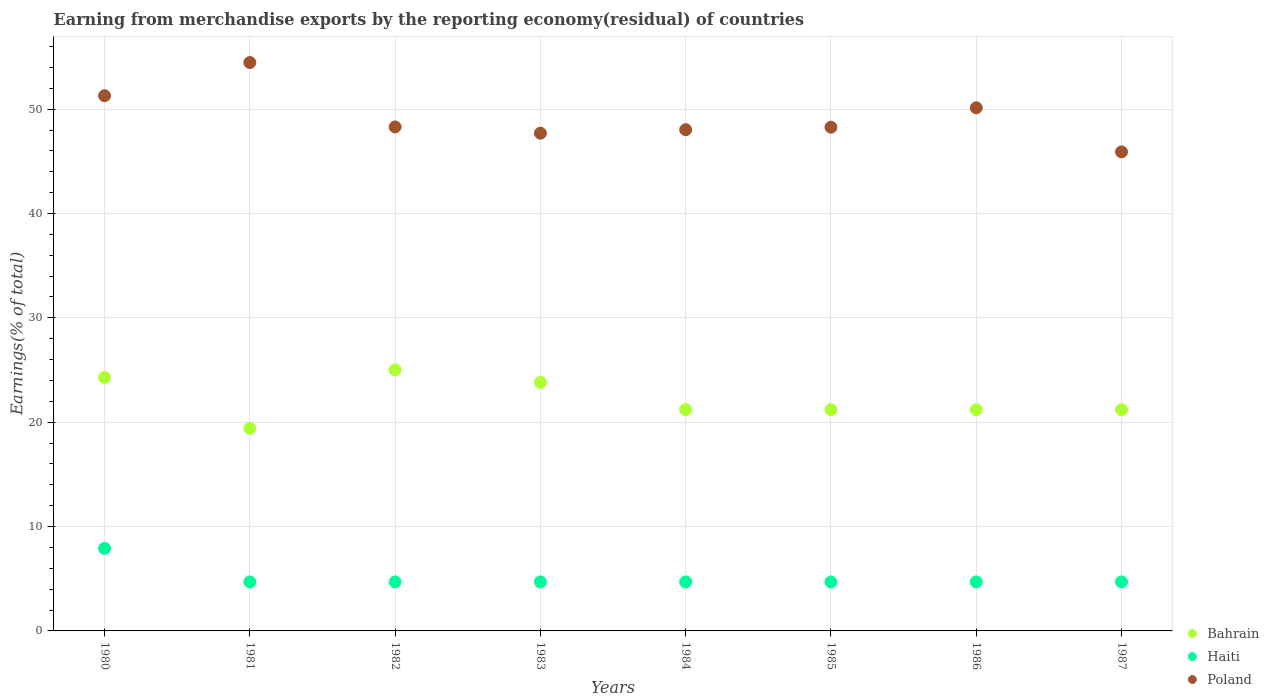How many different coloured dotlines are there?
Keep it short and to the point. 3. What is the percentage of amount earned from merchandise exports in Bahrain in 1986?
Keep it short and to the point. 21.2. Across all years, what is the maximum percentage of amount earned from merchandise exports in Bahrain?
Your answer should be compact. 25.02. Across all years, what is the minimum percentage of amount earned from merchandise exports in Haiti?
Offer a very short reply. 4.7. In which year was the percentage of amount earned from merchandise exports in Haiti minimum?
Offer a terse response. 1983. What is the total percentage of amount earned from merchandise exports in Haiti in the graph?
Your answer should be compact. 40.8. What is the difference between the percentage of amount earned from merchandise exports in Haiti in 1981 and that in 1985?
Ensure brevity in your answer.  1.0363631730569978e-8. What is the difference between the percentage of amount earned from merchandise exports in Haiti in 1983 and the percentage of amount earned from merchandise exports in Bahrain in 1981?
Your answer should be compact. -14.71. What is the average percentage of amount earned from merchandise exports in Bahrain per year?
Make the answer very short. 22.17. In the year 1987, what is the difference between the percentage of amount earned from merchandise exports in Poland and percentage of amount earned from merchandise exports in Bahrain?
Give a very brief answer. 24.71. In how many years, is the percentage of amount earned from merchandise exports in Bahrain greater than 48 %?
Give a very brief answer. 0. What is the ratio of the percentage of amount earned from merchandise exports in Haiti in 1983 to that in 1985?
Your answer should be very brief. 1. Is the percentage of amount earned from merchandise exports in Bahrain in 1980 less than that in 1983?
Offer a terse response. No. What is the difference between the highest and the second highest percentage of amount earned from merchandise exports in Bahrain?
Provide a short and direct response. 0.72. What is the difference between the highest and the lowest percentage of amount earned from merchandise exports in Bahrain?
Offer a very short reply. 5.6. In how many years, is the percentage of amount earned from merchandise exports in Bahrain greater than the average percentage of amount earned from merchandise exports in Bahrain taken over all years?
Give a very brief answer. 3. Is the sum of the percentage of amount earned from merchandise exports in Poland in 1980 and 1984 greater than the maximum percentage of amount earned from merchandise exports in Bahrain across all years?
Ensure brevity in your answer.  Yes. Does the percentage of amount earned from merchandise exports in Bahrain monotonically increase over the years?
Give a very brief answer. No. Are the values on the major ticks of Y-axis written in scientific E-notation?
Your response must be concise. No. How many legend labels are there?
Your answer should be very brief. 3. How are the legend labels stacked?
Your answer should be very brief. Vertical. What is the title of the graph?
Provide a short and direct response. Earning from merchandise exports by the reporting economy(residual) of countries. What is the label or title of the Y-axis?
Give a very brief answer. Earnings(% of total). What is the Earnings(% of total) in Bahrain in 1980?
Offer a terse response. 24.29. What is the Earnings(% of total) of Haiti in 1980?
Offer a very short reply. 7.91. What is the Earnings(% of total) of Poland in 1980?
Give a very brief answer. 51.29. What is the Earnings(% of total) of Bahrain in 1981?
Ensure brevity in your answer.  19.41. What is the Earnings(% of total) in Haiti in 1981?
Offer a very short reply. 4.7. What is the Earnings(% of total) of Poland in 1981?
Your answer should be very brief. 54.47. What is the Earnings(% of total) of Bahrain in 1982?
Make the answer very short. 25.02. What is the Earnings(% of total) in Haiti in 1982?
Provide a succinct answer. 4.7. What is the Earnings(% of total) of Poland in 1982?
Offer a terse response. 48.3. What is the Earnings(% of total) of Bahrain in 1983?
Make the answer very short. 23.83. What is the Earnings(% of total) in Haiti in 1983?
Ensure brevity in your answer.  4.7. What is the Earnings(% of total) in Poland in 1983?
Your answer should be very brief. 47.7. What is the Earnings(% of total) of Bahrain in 1984?
Your response must be concise. 21.2. What is the Earnings(% of total) of Haiti in 1984?
Keep it short and to the point. 4.7. What is the Earnings(% of total) of Poland in 1984?
Your answer should be compact. 48.03. What is the Earnings(% of total) of Bahrain in 1985?
Offer a terse response. 21.2. What is the Earnings(% of total) of Haiti in 1985?
Offer a very short reply. 4.7. What is the Earnings(% of total) of Poland in 1985?
Your answer should be very brief. 48.27. What is the Earnings(% of total) in Bahrain in 1986?
Ensure brevity in your answer.  21.2. What is the Earnings(% of total) of Haiti in 1986?
Offer a very short reply. 4.7. What is the Earnings(% of total) of Poland in 1986?
Your response must be concise. 50.13. What is the Earnings(% of total) in Bahrain in 1987?
Make the answer very short. 21.2. What is the Earnings(% of total) in Haiti in 1987?
Keep it short and to the point. 4.7. What is the Earnings(% of total) of Poland in 1987?
Ensure brevity in your answer.  45.91. Across all years, what is the maximum Earnings(% of total) in Bahrain?
Your response must be concise. 25.02. Across all years, what is the maximum Earnings(% of total) of Haiti?
Make the answer very short. 7.91. Across all years, what is the maximum Earnings(% of total) of Poland?
Your response must be concise. 54.47. Across all years, what is the minimum Earnings(% of total) in Bahrain?
Give a very brief answer. 19.41. Across all years, what is the minimum Earnings(% of total) of Haiti?
Keep it short and to the point. 4.7. Across all years, what is the minimum Earnings(% of total) of Poland?
Your answer should be very brief. 45.91. What is the total Earnings(% of total) of Bahrain in the graph?
Keep it short and to the point. 177.35. What is the total Earnings(% of total) of Haiti in the graph?
Ensure brevity in your answer.  40.8. What is the total Earnings(% of total) of Poland in the graph?
Your answer should be very brief. 394.09. What is the difference between the Earnings(% of total) in Bahrain in 1980 and that in 1981?
Give a very brief answer. 4.88. What is the difference between the Earnings(% of total) of Haiti in 1980 and that in 1981?
Provide a short and direct response. 3.21. What is the difference between the Earnings(% of total) in Poland in 1980 and that in 1981?
Offer a terse response. -3.18. What is the difference between the Earnings(% of total) in Bahrain in 1980 and that in 1982?
Your answer should be compact. -0.72. What is the difference between the Earnings(% of total) of Haiti in 1980 and that in 1982?
Your response must be concise. 3.21. What is the difference between the Earnings(% of total) of Poland in 1980 and that in 1982?
Offer a terse response. 2.99. What is the difference between the Earnings(% of total) in Bahrain in 1980 and that in 1983?
Your answer should be compact. 0.47. What is the difference between the Earnings(% of total) of Haiti in 1980 and that in 1983?
Ensure brevity in your answer.  3.21. What is the difference between the Earnings(% of total) of Poland in 1980 and that in 1983?
Provide a succinct answer. 3.59. What is the difference between the Earnings(% of total) in Bahrain in 1980 and that in 1984?
Your response must be concise. 3.09. What is the difference between the Earnings(% of total) in Haiti in 1980 and that in 1984?
Ensure brevity in your answer.  3.21. What is the difference between the Earnings(% of total) of Poland in 1980 and that in 1984?
Your answer should be very brief. 3.26. What is the difference between the Earnings(% of total) in Bahrain in 1980 and that in 1985?
Offer a terse response. 3.09. What is the difference between the Earnings(% of total) of Haiti in 1980 and that in 1985?
Your response must be concise. 3.21. What is the difference between the Earnings(% of total) of Poland in 1980 and that in 1985?
Offer a terse response. 3.02. What is the difference between the Earnings(% of total) of Bahrain in 1980 and that in 1986?
Your answer should be very brief. 3.09. What is the difference between the Earnings(% of total) in Haiti in 1980 and that in 1986?
Your response must be concise. 3.21. What is the difference between the Earnings(% of total) of Poland in 1980 and that in 1986?
Provide a short and direct response. 1.16. What is the difference between the Earnings(% of total) in Bahrain in 1980 and that in 1987?
Give a very brief answer. 3.09. What is the difference between the Earnings(% of total) in Haiti in 1980 and that in 1987?
Your answer should be compact. 3.21. What is the difference between the Earnings(% of total) in Poland in 1980 and that in 1987?
Offer a terse response. 5.38. What is the difference between the Earnings(% of total) of Bahrain in 1981 and that in 1982?
Make the answer very short. -5.6. What is the difference between the Earnings(% of total) of Haiti in 1981 and that in 1982?
Ensure brevity in your answer.  0. What is the difference between the Earnings(% of total) of Poland in 1981 and that in 1982?
Ensure brevity in your answer.  6.17. What is the difference between the Earnings(% of total) of Bahrain in 1981 and that in 1983?
Keep it short and to the point. -4.41. What is the difference between the Earnings(% of total) in Poland in 1981 and that in 1983?
Keep it short and to the point. 6.77. What is the difference between the Earnings(% of total) of Bahrain in 1981 and that in 1984?
Your response must be concise. -1.79. What is the difference between the Earnings(% of total) in Poland in 1981 and that in 1984?
Offer a terse response. 6.44. What is the difference between the Earnings(% of total) in Bahrain in 1981 and that in 1985?
Your answer should be compact. -1.79. What is the difference between the Earnings(% of total) in Poland in 1981 and that in 1985?
Your answer should be compact. 6.2. What is the difference between the Earnings(% of total) of Bahrain in 1981 and that in 1986?
Your answer should be compact. -1.79. What is the difference between the Earnings(% of total) in Poland in 1981 and that in 1986?
Give a very brief answer. 4.34. What is the difference between the Earnings(% of total) of Bahrain in 1981 and that in 1987?
Give a very brief answer. -1.79. What is the difference between the Earnings(% of total) in Haiti in 1981 and that in 1987?
Give a very brief answer. -0. What is the difference between the Earnings(% of total) of Poland in 1981 and that in 1987?
Provide a short and direct response. 8.56. What is the difference between the Earnings(% of total) of Bahrain in 1982 and that in 1983?
Ensure brevity in your answer.  1.19. What is the difference between the Earnings(% of total) of Haiti in 1982 and that in 1983?
Provide a short and direct response. 0. What is the difference between the Earnings(% of total) in Poland in 1982 and that in 1983?
Make the answer very short. 0.6. What is the difference between the Earnings(% of total) of Bahrain in 1982 and that in 1984?
Offer a terse response. 3.82. What is the difference between the Earnings(% of total) of Poland in 1982 and that in 1984?
Your answer should be very brief. 0.27. What is the difference between the Earnings(% of total) of Bahrain in 1982 and that in 1985?
Give a very brief answer. 3.82. What is the difference between the Earnings(% of total) in Haiti in 1982 and that in 1985?
Keep it short and to the point. -0. What is the difference between the Earnings(% of total) of Poland in 1982 and that in 1985?
Ensure brevity in your answer.  0.03. What is the difference between the Earnings(% of total) in Bahrain in 1982 and that in 1986?
Your response must be concise. 3.82. What is the difference between the Earnings(% of total) in Haiti in 1982 and that in 1986?
Ensure brevity in your answer.  -0. What is the difference between the Earnings(% of total) of Poland in 1982 and that in 1986?
Give a very brief answer. -1.83. What is the difference between the Earnings(% of total) in Bahrain in 1982 and that in 1987?
Your answer should be compact. 3.82. What is the difference between the Earnings(% of total) in Haiti in 1982 and that in 1987?
Your response must be concise. -0. What is the difference between the Earnings(% of total) in Poland in 1982 and that in 1987?
Offer a terse response. 2.39. What is the difference between the Earnings(% of total) of Bahrain in 1983 and that in 1984?
Keep it short and to the point. 2.63. What is the difference between the Earnings(% of total) of Haiti in 1983 and that in 1984?
Offer a terse response. -0. What is the difference between the Earnings(% of total) in Poland in 1983 and that in 1984?
Your answer should be very brief. -0.34. What is the difference between the Earnings(% of total) in Bahrain in 1983 and that in 1985?
Provide a succinct answer. 2.63. What is the difference between the Earnings(% of total) of Poland in 1983 and that in 1985?
Keep it short and to the point. -0.57. What is the difference between the Earnings(% of total) in Bahrain in 1983 and that in 1986?
Ensure brevity in your answer.  2.63. What is the difference between the Earnings(% of total) of Poland in 1983 and that in 1986?
Provide a succinct answer. -2.44. What is the difference between the Earnings(% of total) of Bahrain in 1983 and that in 1987?
Your response must be concise. 2.63. What is the difference between the Earnings(% of total) in Poland in 1983 and that in 1987?
Ensure brevity in your answer.  1.79. What is the difference between the Earnings(% of total) in Poland in 1984 and that in 1985?
Your answer should be very brief. -0.24. What is the difference between the Earnings(% of total) of Bahrain in 1984 and that in 1986?
Your answer should be very brief. -0. What is the difference between the Earnings(% of total) of Poland in 1984 and that in 1986?
Offer a terse response. -2.1. What is the difference between the Earnings(% of total) of Bahrain in 1984 and that in 1987?
Keep it short and to the point. -0. What is the difference between the Earnings(% of total) of Poland in 1984 and that in 1987?
Offer a very short reply. 2.13. What is the difference between the Earnings(% of total) in Bahrain in 1985 and that in 1986?
Offer a very short reply. 0. What is the difference between the Earnings(% of total) of Haiti in 1985 and that in 1986?
Provide a short and direct response. -0. What is the difference between the Earnings(% of total) in Poland in 1985 and that in 1986?
Provide a short and direct response. -1.86. What is the difference between the Earnings(% of total) of Bahrain in 1985 and that in 1987?
Your answer should be compact. -0. What is the difference between the Earnings(% of total) in Haiti in 1985 and that in 1987?
Offer a very short reply. -0. What is the difference between the Earnings(% of total) in Poland in 1985 and that in 1987?
Give a very brief answer. 2.37. What is the difference between the Earnings(% of total) in Haiti in 1986 and that in 1987?
Your answer should be very brief. 0. What is the difference between the Earnings(% of total) of Poland in 1986 and that in 1987?
Provide a succinct answer. 4.23. What is the difference between the Earnings(% of total) of Bahrain in 1980 and the Earnings(% of total) of Haiti in 1981?
Offer a very short reply. 19.59. What is the difference between the Earnings(% of total) of Bahrain in 1980 and the Earnings(% of total) of Poland in 1981?
Your answer should be compact. -30.18. What is the difference between the Earnings(% of total) in Haiti in 1980 and the Earnings(% of total) in Poland in 1981?
Make the answer very short. -46.56. What is the difference between the Earnings(% of total) in Bahrain in 1980 and the Earnings(% of total) in Haiti in 1982?
Your answer should be very brief. 19.59. What is the difference between the Earnings(% of total) of Bahrain in 1980 and the Earnings(% of total) of Poland in 1982?
Ensure brevity in your answer.  -24.01. What is the difference between the Earnings(% of total) in Haiti in 1980 and the Earnings(% of total) in Poland in 1982?
Provide a short and direct response. -40.39. What is the difference between the Earnings(% of total) in Bahrain in 1980 and the Earnings(% of total) in Haiti in 1983?
Keep it short and to the point. 19.59. What is the difference between the Earnings(% of total) in Bahrain in 1980 and the Earnings(% of total) in Poland in 1983?
Offer a terse response. -23.4. What is the difference between the Earnings(% of total) in Haiti in 1980 and the Earnings(% of total) in Poland in 1983?
Provide a succinct answer. -39.78. What is the difference between the Earnings(% of total) of Bahrain in 1980 and the Earnings(% of total) of Haiti in 1984?
Your answer should be very brief. 19.59. What is the difference between the Earnings(% of total) in Bahrain in 1980 and the Earnings(% of total) in Poland in 1984?
Offer a terse response. -23.74. What is the difference between the Earnings(% of total) in Haiti in 1980 and the Earnings(% of total) in Poland in 1984?
Your response must be concise. -40.12. What is the difference between the Earnings(% of total) of Bahrain in 1980 and the Earnings(% of total) of Haiti in 1985?
Offer a very short reply. 19.59. What is the difference between the Earnings(% of total) in Bahrain in 1980 and the Earnings(% of total) in Poland in 1985?
Your answer should be very brief. -23.98. What is the difference between the Earnings(% of total) in Haiti in 1980 and the Earnings(% of total) in Poland in 1985?
Your answer should be compact. -40.36. What is the difference between the Earnings(% of total) of Bahrain in 1980 and the Earnings(% of total) of Haiti in 1986?
Your answer should be compact. 19.59. What is the difference between the Earnings(% of total) of Bahrain in 1980 and the Earnings(% of total) of Poland in 1986?
Keep it short and to the point. -25.84. What is the difference between the Earnings(% of total) in Haiti in 1980 and the Earnings(% of total) in Poland in 1986?
Make the answer very short. -42.22. What is the difference between the Earnings(% of total) in Bahrain in 1980 and the Earnings(% of total) in Haiti in 1987?
Offer a very short reply. 19.59. What is the difference between the Earnings(% of total) in Bahrain in 1980 and the Earnings(% of total) in Poland in 1987?
Your answer should be very brief. -21.61. What is the difference between the Earnings(% of total) of Haiti in 1980 and the Earnings(% of total) of Poland in 1987?
Give a very brief answer. -37.99. What is the difference between the Earnings(% of total) in Bahrain in 1981 and the Earnings(% of total) in Haiti in 1982?
Keep it short and to the point. 14.71. What is the difference between the Earnings(% of total) of Bahrain in 1981 and the Earnings(% of total) of Poland in 1982?
Provide a short and direct response. -28.89. What is the difference between the Earnings(% of total) of Haiti in 1981 and the Earnings(% of total) of Poland in 1982?
Keep it short and to the point. -43.6. What is the difference between the Earnings(% of total) of Bahrain in 1981 and the Earnings(% of total) of Haiti in 1983?
Make the answer very short. 14.71. What is the difference between the Earnings(% of total) of Bahrain in 1981 and the Earnings(% of total) of Poland in 1983?
Give a very brief answer. -28.28. What is the difference between the Earnings(% of total) in Haiti in 1981 and the Earnings(% of total) in Poland in 1983?
Your response must be concise. -43. What is the difference between the Earnings(% of total) of Bahrain in 1981 and the Earnings(% of total) of Haiti in 1984?
Keep it short and to the point. 14.71. What is the difference between the Earnings(% of total) in Bahrain in 1981 and the Earnings(% of total) in Poland in 1984?
Your answer should be very brief. -28.62. What is the difference between the Earnings(% of total) in Haiti in 1981 and the Earnings(% of total) in Poland in 1984?
Your response must be concise. -43.33. What is the difference between the Earnings(% of total) of Bahrain in 1981 and the Earnings(% of total) of Haiti in 1985?
Offer a terse response. 14.71. What is the difference between the Earnings(% of total) of Bahrain in 1981 and the Earnings(% of total) of Poland in 1985?
Your response must be concise. -28.86. What is the difference between the Earnings(% of total) of Haiti in 1981 and the Earnings(% of total) of Poland in 1985?
Provide a succinct answer. -43.57. What is the difference between the Earnings(% of total) in Bahrain in 1981 and the Earnings(% of total) in Haiti in 1986?
Ensure brevity in your answer.  14.71. What is the difference between the Earnings(% of total) in Bahrain in 1981 and the Earnings(% of total) in Poland in 1986?
Offer a terse response. -30.72. What is the difference between the Earnings(% of total) of Haiti in 1981 and the Earnings(% of total) of Poland in 1986?
Offer a very short reply. -45.43. What is the difference between the Earnings(% of total) in Bahrain in 1981 and the Earnings(% of total) in Haiti in 1987?
Provide a succinct answer. 14.71. What is the difference between the Earnings(% of total) in Bahrain in 1981 and the Earnings(% of total) in Poland in 1987?
Your answer should be compact. -26.49. What is the difference between the Earnings(% of total) in Haiti in 1981 and the Earnings(% of total) in Poland in 1987?
Give a very brief answer. -41.21. What is the difference between the Earnings(% of total) in Bahrain in 1982 and the Earnings(% of total) in Haiti in 1983?
Your answer should be compact. 20.32. What is the difference between the Earnings(% of total) of Bahrain in 1982 and the Earnings(% of total) of Poland in 1983?
Ensure brevity in your answer.  -22.68. What is the difference between the Earnings(% of total) in Haiti in 1982 and the Earnings(% of total) in Poland in 1983?
Your response must be concise. -43. What is the difference between the Earnings(% of total) in Bahrain in 1982 and the Earnings(% of total) in Haiti in 1984?
Give a very brief answer. 20.32. What is the difference between the Earnings(% of total) of Bahrain in 1982 and the Earnings(% of total) of Poland in 1984?
Ensure brevity in your answer.  -23.02. What is the difference between the Earnings(% of total) of Haiti in 1982 and the Earnings(% of total) of Poland in 1984?
Offer a terse response. -43.33. What is the difference between the Earnings(% of total) in Bahrain in 1982 and the Earnings(% of total) in Haiti in 1985?
Your response must be concise. 20.32. What is the difference between the Earnings(% of total) in Bahrain in 1982 and the Earnings(% of total) in Poland in 1985?
Give a very brief answer. -23.25. What is the difference between the Earnings(% of total) of Haiti in 1982 and the Earnings(% of total) of Poland in 1985?
Give a very brief answer. -43.57. What is the difference between the Earnings(% of total) in Bahrain in 1982 and the Earnings(% of total) in Haiti in 1986?
Your answer should be compact. 20.32. What is the difference between the Earnings(% of total) in Bahrain in 1982 and the Earnings(% of total) in Poland in 1986?
Offer a very short reply. -25.12. What is the difference between the Earnings(% of total) in Haiti in 1982 and the Earnings(% of total) in Poland in 1986?
Provide a succinct answer. -45.43. What is the difference between the Earnings(% of total) of Bahrain in 1982 and the Earnings(% of total) of Haiti in 1987?
Offer a terse response. 20.32. What is the difference between the Earnings(% of total) in Bahrain in 1982 and the Earnings(% of total) in Poland in 1987?
Provide a succinct answer. -20.89. What is the difference between the Earnings(% of total) in Haiti in 1982 and the Earnings(% of total) in Poland in 1987?
Offer a terse response. -41.21. What is the difference between the Earnings(% of total) of Bahrain in 1983 and the Earnings(% of total) of Haiti in 1984?
Ensure brevity in your answer.  19.13. What is the difference between the Earnings(% of total) of Bahrain in 1983 and the Earnings(% of total) of Poland in 1984?
Make the answer very short. -24.21. What is the difference between the Earnings(% of total) of Haiti in 1983 and the Earnings(% of total) of Poland in 1984?
Your response must be concise. -43.33. What is the difference between the Earnings(% of total) of Bahrain in 1983 and the Earnings(% of total) of Haiti in 1985?
Offer a terse response. 19.13. What is the difference between the Earnings(% of total) of Bahrain in 1983 and the Earnings(% of total) of Poland in 1985?
Your answer should be very brief. -24.44. What is the difference between the Earnings(% of total) of Haiti in 1983 and the Earnings(% of total) of Poland in 1985?
Offer a terse response. -43.57. What is the difference between the Earnings(% of total) in Bahrain in 1983 and the Earnings(% of total) in Haiti in 1986?
Make the answer very short. 19.13. What is the difference between the Earnings(% of total) of Bahrain in 1983 and the Earnings(% of total) of Poland in 1986?
Provide a succinct answer. -26.31. What is the difference between the Earnings(% of total) in Haiti in 1983 and the Earnings(% of total) in Poland in 1986?
Make the answer very short. -45.43. What is the difference between the Earnings(% of total) in Bahrain in 1983 and the Earnings(% of total) in Haiti in 1987?
Ensure brevity in your answer.  19.13. What is the difference between the Earnings(% of total) of Bahrain in 1983 and the Earnings(% of total) of Poland in 1987?
Offer a very short reply. -22.08. What is the difference between the Earnings(% of total) in Haiti in 1983 and the Earnings(% of total) in Poland in 1987?
Your answer should be compact. -41.21. What is the difference between the Earnings(% of total) in Bahrain in 1984 and the Earnings(% of total) in Haiti in 1985?
Keep it short and to the point. 16.5. What is the difference between the Earnings(% of total) of Bahrain in 1984 and the Earnings(% of total) of Poland in 1985?
Offer a terse response. -27.07. What is the difference between the Earnings(% of total) in Haiti in 1984 and the Earnings(% of total) in Poland in 1985?
Offer a very short reply. -43.57. What is the difference between the Earnings(% of total) of Bahrain in 1984 and the Earnings(% of total) of Haiti in 1986?
Provide a succinct answer. 16.5. What is the difference between the Earnings(% of total) of Bahrain in 1984 and the Earnings(% of total) of Poland in 1986?
Your answer should be compact. -28.93. What is the difference between the Earnings(% of total) of Haiti in 1984 and the Earnings(% of total) of Poland in 1986?
Give a very brief answer. -45.43. What is the difference between the Earnings(% of total) in Bahrain in 1984 and the Earnings(% of total) in Haiti in 1987?
Offer a terse response. 16.5. What is the difference between the Earnings(% of total) of Bahrain in 1984 and the Earnings(% of total) of Poland in 1987?
Offer a very short reply. -24.7. What is the difference between the Earnings(% of total) of Haiti in 1984 and the Earnings(% of total) of Poland in 1987?
Your answer should be very brief. -41.21. What is the difference between the Earnings(% of total) in Bahrain in 1985 and the Earnings(% of total) in Haiti in 1986?
Offer a terse response. 16.5. What is the difference between the Earnings(% of total) in Bahrain in 1985 and the Earnings(% of total) in Poland in 1986?
Offer a terse response. -28.93. What is the difference between the Earnings(% of total) in Haiti in 1985 and the Earnings(% of total) in Poland in 1986?
Your answer should be compact. -45.43. What is the difference between the Earnings(% of total) in Bahrain in 1985 and the Earnings(% of total) in Haiti in 1987?
Provide a short and direct response. 16.5. What is the difference between the Earnings(% of total) of Bahrain in 1985 and the Earnings(% of total) of Poland in 1987?
Make the answer very short. -24.7. What is the difference between the Earnings(% of total) of Haiti in 1985 and the Earnings(% of total) of Poland in 1987?
Your answer should be compact. -41.21. What is the difference between the Earnings(% of total) in Bahrain in 1986 and the Earnings(% of total) in Haiti in 1987?
Keep it short and to the point. 16.5. What is the difference between the Earnings(% of total) of Bahrain in 1986 and the Earnings(% of total) of Poland in 1987?
Ensure brevity in your answer.  -24.7. What is the difference between the Earnings(% of total) in Haiti in 1986 and the Earnings(% of total) in Poland in 1987?
Make the answer very short. -41.21. What is the average Earnings(% of total) in Bahrain per year?
Your answer should be compact. 22.17. What is the average Earnings(% of total) in Haiti per year?
Your answer should be compact. 5.1. What is the average Earnings(% of total) in Poland per year?
Ensure brevity in your answer.  49.26. In the year 1980, what is the difference between the Earnings(% of total) of Bahrain and Earnings(% of total) of Haiti?
Your response must be concise. 16.38. In the year 1980, what is the difference between the Earnings(% of total) of Bahrain and Earnings(% of total) of Poland?
Offer a terse response. -27. In the year 1980, what is the difference between the Earnings(% of total) of Haiti and Earnings(% of total) of Poland?
Offer a very short reply. -43.38. In the year 1981, what is the difference between the Earnings(% of total) of Bahrain and Earnings(% of total) of Haiti?
Make the answer very short. 14.71. In the year 1981, what is the difference between the Earnings(% of total) in Bahrain and Earnings(% of total) in Poland?
Your answer should be compact. -35.06. In the year 1981, what is the difference between the Earnings(% of total) in Haiti and Earnings(% of total) in Poland?
Ensure brevity in your answer.  -49.77. In the year 1982, what is the difference between the Earnings(% of total) of Bahrain and Earnings(% of total) of Haiti?
Keep it short and to the point. 20.32. In the year 1982, what is the difference between the Earnings(% of total) of Bahrain and Earnings(% of total) of Poland?
Give a very brief answer. -23.28. In the year 1982, what is the difference between the Earnings(% of total) in Haiti and Earnings(% of total) in Poland?
Provide a succinct answer. -43.6. In the year 1983, what is the difference between the Earnings(% of total) in Bahrain and Earnings(% of total) in Haiti?
Keep it short and to the point. 19.13. In the year 1983, what is the difference between the Earnings(% of total) in Bahrain and Earnings(% of total) in Poland?
Keep it short and to the point. -23.87. In the year 1983, what is the difference between the Earnings(% of total) of Haiti and Earnings(% of total) of Poland?
Your answer should be very brief. -43. In the year 1984, what is the difference between the Earnings(% of total) in Bahrain and Earnings(% of total) in Haiti?
Provide a short and direct response. 16.5. In the year 1984, what is the difference between the Earnings(% of total) in Bahrain and Earnings(% of total) in Poland?
Your answer should be very brief. -26.83. In the year 1984, what is the difference between the Earnings(% of total) in Haiti and Earnings(% of total) in Poland?
Make the answer very short. -43.33. In the year 1985, what is the difference between the Earnings(% of total) in Bahrain and Earnings(% of total) in Haiti?
Provide a short and direct response. 16.5. In the year 1985, what is the difference between the Earnings(% of total) in Bahrain and Earnings(% of total) in Poland?
Ensure brevity in your answer.  -27.07. In the year 1985, what is the difference between the Earnings(% of total) of Haiti and Earnings(% of total) of Poland?
Offer a very short reply. -43.57. In the year 1986, what is the difference between the Earnings(% of total) in Bahrain and Earnings(% of total) in Haiti?
Your answer should be very brief. 16.5. In the year 1986, what is the difference between the Earnings(% of total) in Bahrain and Earnings(% of total) in Poland?
Your answer should be compact. -28.93. In the year 1986, what is the difference between the Earnings(% of total) in Haiti and Earnings(% of total) in Poland?
Your answer should be compact. -45.43. In the year 1987, what is the difference between the Earnings(% of total) in Bahrain and Earnings(% of total) in Haiti?
Keep it short and to the point. 16.5. In the year 1987, what is the difference between the Earnings(% of total) of Bahrain and Earnings(% of total) of Poland?
Ensure brevity in your answer.  -24.7. In the year 1987, what is the difference between the Earnings(% of total) of Haiti and Earnings(% of total) of Poland?
Make the answer very short. -41.21. What is the ratio of the Earnings(% of total) of Bahrain in 1980 to that in 1981?
Your response must be concise. 1.25. What is the ratio of the Earnings(% of total) in Haiti in 1980 to that in 1981?
Your response must be concise. 1.68. What is the ratio of the Earnings(% of total) of Poland in 1980 to that in 1981?
Your answer should be very brief. 0.94. What is the ratio of the Earnings(% of total) in Bahrain in 1980 to that in 1982?
Make the answer very short. 0.97. What is the ratio of the Earnings(% of total) in Haiti in 1980 to that in 1982?
Offer a very short reply. 1.68. What is the ratio of the Earnings(% of total) in Poland in 1980 to that in 1982?
Your answer should be compact. 1.06. What is the ratio of the Earnings(% of total) of Bahrain in 1980 to that in 1983?
Ensure brevity in your answer.  1.02. What is the ratio of the Earnings(% of total) of Haiti in 1980 to that in 1983?
Offer a very short reply. 1.68. What is the ratio of the Earnings(% of total) of Poland in 1980 to that in 1983?
Provide a short and direct response. 1.08. What is the ratio of the Earnings(% of total) in Bahrain in 1980 to that in 1984?
Your answer should be very brief. 1.15. What is the ratio of the Earnings(% of total) in Haiti in 1980 to that in 1984?
Keep it short and to the point. 1.68. What is the ratio of the Earnings(% of total) in Poland in 1980 to that in 1984?
Provide a succinct answer. 1.07. What is the ratio of the Earnings(% of total) in Bahrain in 1980 to that in 1985?
Your answer should be very brief. 1.15. What is the ratio of the Earnings(% of total) in Haiti in 1980 to that in 1985?
Keep it short and to the point. 1.68. What is the ratio of the Earnings(% of total) in Bahrain in 1980 to that in 1986?
Keep it short and to the point. 1.15. What is the ratio of the Earnings(% of total) of Haiti in 1980 to that in 1986?
Provide a short and direct response. 1.68. What is the ratio of the Earnings(% of total) in Poland in 1980 to that in 1986?
Your response must be concise. 1.02. What is the ratio of the Earnings(% of total) of Bahrain in 1980 to that in 1987?
Your answer should be very brief. 1.15. What is the ratio of the Earnings(% of total) of Haiti in 1980 to that in 1987?
Offer a very short reply. 1.68. What is the ratio of the Earnings(% of total) in Poland in 1980 to that in 1987?
Keep it short and to the point. 1.12. What is the ratio of the Earnings(% of total) of Bahrain in 1981 to that in 1982?
Your answer should be very brief. 0.78. What is the ratio of the Earnings(% of total) in Poland in 1981 to that in 1982?
Your answer should be compact. 1.13. What is the ratio of the Earnings(% of total) in Bahrain in 1981 to that in 1983?
Your answer should be compact. 0.81. What is the ratio of the Earnings(% of total) of Haiti in 1981 to that in 1983?
Keep it short and to the point. 1. What is the ratio of the Earnings(% of total) in Poland in 1981 to that in 1983?
Provide a short and direct response. 1.14. What is the ratio of the Earnings(% of total) in Bahrain in 1981 to that in 1984?
Provide a short and direct response. 0.92. What is the ratio of the Earnings(% of total) in Haiti in 1981 to that in 1984?
Make the answer very short. 1. What is the ratio of the Earnings(% of total) in Poland in 1981 to that in 1984?
Give a very brief answer. 1.13. What is the ratio of the Earnings(% of total) of Bahrain in 1981 to that in 1985?
Provide a short and direct response. 0.92. What is the ratio of the Earnings(% of total) in Poland in 1981 to that in 1985?
Your response must be concise. 1.13. What is the ratio of the Earnings(% of total) of Bahrain in 1981 to that in 1986?
Keep it short and to the point. 0.92. What is the ratio of the Earnings(% of total) of Poland in 1981 to that in 1986?
Offer a terse response. 1.09. What is the ratio of the Earnings(% of total) of Bahrain in 1981 to that in 1987?
Give a very brief answer. 0.92. What is the ratio of the Earnings(% of total) in Poland in 1981 to that in 1987?
Ensure brevity in your answer.  1.19. What is the ratio of the Earnings(% of total) of Haiti in 1982 to that in 1983?
Your answer should be compact. 1. What is the ratio of the Earnings(% of total) of Poland in 1982 to that in 1983?
Your response must be concise. 1.01. What is the ratio of the Earnings(% of total) of Bahrain in 1982 to that in 1984?
Keep it short and to the point. 1.18. What is the ratio of the Earnings(% of total) of Haiti in 1982 to that in 1984?
Offer a terse response. 1. What is the ratio of the Earnings(% of total) of Poland in 1982 to that in 1984?
Keep it short and to the point. 1.01. What is the ratio of the Earnings(% of total) in Bahrain in 1982 to that in 1985?
Provide a succinct answer. 1.18. What is the ratio of the Earnings(% of total) of Bahrain in 1982 to that in 1986?
Your response must be concise. 1.18. What is the ratio of the Earnings(% of total) in Poland in 1982 to that in 1986?
Give a very brief answer. 0.96. What is the ratio of the Earnings(% of total) in Bahrain in 1982 to that in 1987?
Your answer should be compact. 1.18. What is the ratio of the Earnings(% of total) of Haiti in 1982 to that in 1987?
Offer a very short reply. 1. What is the ratio of the Earnings(% of total) in Poland in 1982 to that in 1987?
Make the answer very short. 1.05. What is the ratio of the Earnings(% of total) of Bahrain in 1983 to that in 1984?
Your answer should be compact. 1.12. What is the ratio of the Earnings(% of total) in Poland in 1983 to that in 1984?
Provide a succinct answer. 0.99. What is the ratio of the Earnings(% of total) of Bahrain in 1983 to that in 1985?
Keep it short and to the point. 1.12. What is the ratio of the Earnings(% of total) of Haiti in 1983 to that in 1985?
Give a very brief answer. 1. What is the ratio of the Earnings(% of total) in Bahrain in 1983 to that in 1986?
Give a very brief answer. 1.12. What is the ratio of the Earnings(% of total) in Poland in 1983 to that in 1986?
Your answer should be compact. 0.95. What is the ratio of the Earnings(% of total) of Bahrain in 1983 to that in 1987?
Ensure brevity in your answer.  1.12. What is the ratio of the Earnings(% of total) of Poland in 1983 to that in 1987?
Offer a terse response. 1.04. What is the ratio of the Earnings(% of total) in Poland in 1984 to that in 1985?
Offer a very short reply. 1. What is the ratio of the Earnings(% of total) of Poland in 1984 to that in 1986?
Keep it short and to the point. 0.96. What is the ratio of the Earnings(% of total) in Bahrain in 1984 to that in 1987?
Your response must be concise. 1. What is the ratio of the Earnings(% of total) in Haiti in 1984 to that in 1987?
Offer a very short reply. 1. What is the ratio of the Earnings(% of total) of Poland in 1984 to that in 1987?
Your answer should be compact. 1.05. What is the ratio of the Earnings(% of total) in Bahrain in 1985 to that in 1986?
Your answer should be very brief. 1. What is the ratio of the Earnings(% of total) in Haiti in 1985 to that in 1986?
Offer a very short reply. 1. What is the ratio of the Earnings(% of total) in Poland in 1985 to that in 1986?
Ensure brevity in your answer.  0.96. What is the ratio of the Earnings(% of total) of Haiti in 1985 to that in 1987?
Offer a terse response. 1. What is the ratio of the Earnings(% of total) in Poland in 1985 to that in 1987?
Offer a very short reply. 1.05. What is the ratio of the Earnings(% of total) in Poland in 1986 to that in 1987?
Ensure brevity in your answer.  1.09. What is the difference between the highest and the second highest Earnings(% of total) in Bahrain?
Provide a succinct answer. 0.72. What is the difference between the highest and the second highest Earnings(% of total) of Haiti?
Offer a terse response. 3.21. What is the difference between the highest and the second highest Earnings(% of total) of Poland?
Your response must be concise. 3.18. What is the difference between the highest and the lowest Earnings(% of total) of Bahrain?
Provide a succinct answer. 5.6. What is the difference between the highest and the lowest Earnings(% of total) in Haiti?
Provide a succinct answer. 3.21. What is the difference between the highest and the lowest Earnings(% of total) in Poland?
Provide a short and direct response. 8.56. 